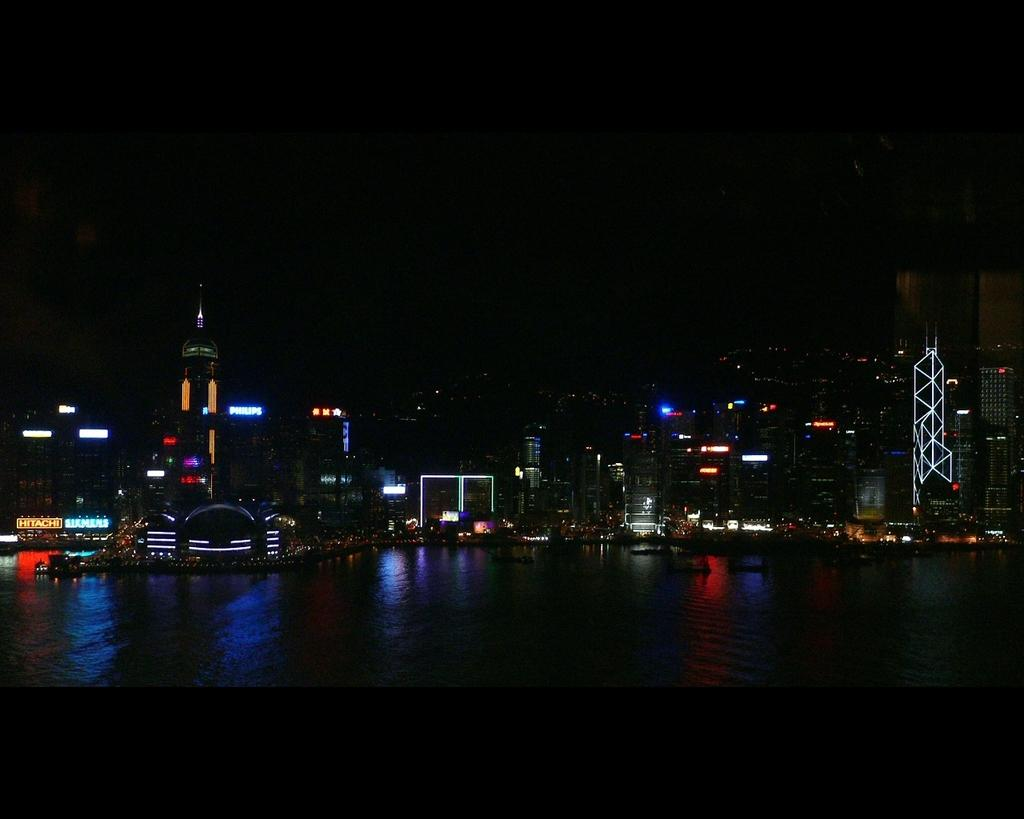What is present at the bottom of the image? There is water at the bottom of the image. What can be seen in the distance in the image? There are buildings in the background of the image. What feature do the buildings in the image have? The buildings have lights. How would you describe the overall color of the background in the image? The background is dark in color. What type of event is taking place in the basin in the image? There is no basin present in the image, and therefore no event can be observed taking place in it. What kind of beast can be seen roaming around the buildings in the image? There are no beasts present in the image; only buildings with lights can be seen in the background. 